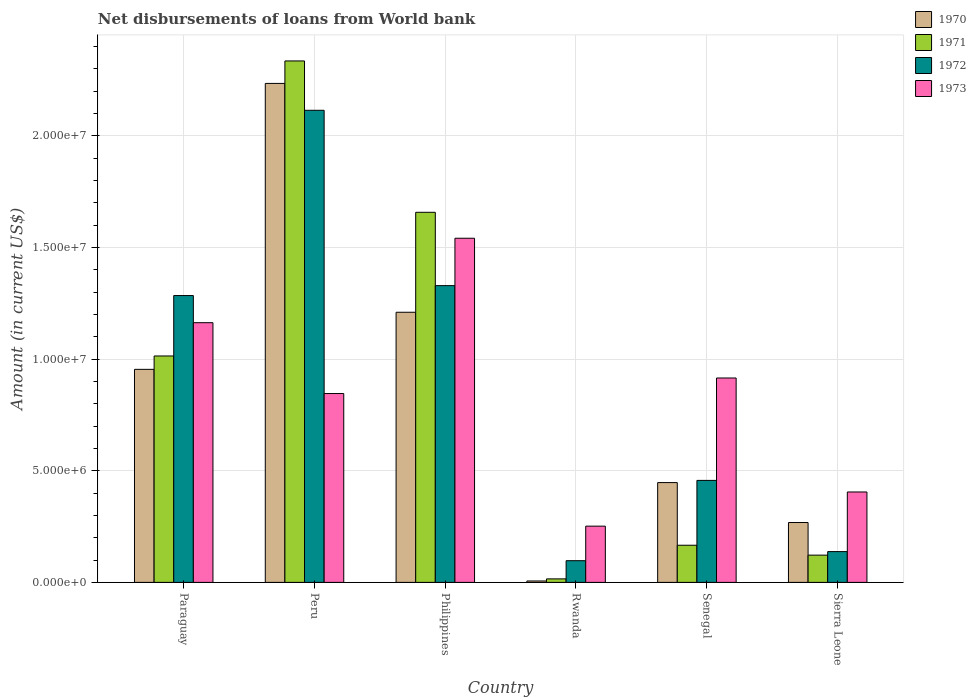How many different coloured bars are there?
Your answer should be compact. 4. How many bars are there on the 2nd tick from the left?
Offer a terse response. 4. What is the label of the 6th group of bars from the left?
Your answer should be very brief. Sierra Leone. In how many cases, is the number of bars for a given country not equal to the number of legend labels?
Ensure brevity in your answer.  0. What is the amount of loan disbursed from World Bank in 1970 in Rwanda?
Make the answer very short. 6.30e+04. Across all countries, what is the maximum amount of loan disbursed from World Bank in 1972?
Offer a terse response. 2.11e+07. Across all countries, what is the minimum amount of loan disbursed from World Bank in 1971?
Your answer should be very brief. 1.57e+05. In which country was the amount of loan disbursed from World Bank in 1973 minimum?
Keep it short and to the point. Rwanda. What is the total amount of loan disbursed from World Bank in 1970 in the graph?
Offer a very short reply. 5.12e+07. What is the difference between the amount of loan disbursed from World Bank in 1971 in Philippines and that in Senegal?
Your answer should be compact. 1.49e+07. What is the difference between the amount of loan disbursed from World Bank in 1971 in Paraguay and the amount of loan disbursed from World Bank in 1970 in Senegal?
Offer a terse response. 5.67e+06. What is the average amount of loan disbursed from World Bank in 1971 per country?
Make the answer very short. 8.85e+06. What is the difference between the amount of loan disbursed from World Bank of/in 1973 and amount of loan disbursed from World Bank of/in 1970 in Senegal?
Give a very brief answer. 4.68e+06. In how many countries, is the amount of loan disbursed from World Bank in 1971 greater than 23000000 US$?
Your answer should be compact. 1. What is the ratio of the amount of loan disbursed from World Bank in 1972 in Philippines to that in Senegal?
Your answer should be compact. 2.91. Is the amount of loan disbursed from World Bank in 1971 in Peru less than that in Sierra Leone?
Provide a short and direct response. No. What is the difference between the highest and the second highest amount of loan disbursed from World Bank in 1970?
Give a very brief answer. 1.02e+07. What is the difference between the highest and the lowest amount of loan disbursed from World Bank in 1970?
Provide a succinct answer. 2.23e+07. Is it the case that in every country, the sum of the amount of loan disbursed from World Bank in 1973 and amount of loan disbursed from World Bank in 1972 is greater than the sum of amount of loan disbursed from World Bank in 1971 and amount of loan disbursed from World Bank in 1970?
Make the answer very short. No. What does the 1st bar from the left in Sierra Leone represents?
Offer a terse response. 1970. How many bars are there?
Give a very brief answer. 24. How many countries are there in the graph?
Your answer should be compact. 6. What is the difference between two consecutive major ticks on the Y-axis?
Your response must be concise. 5.00e+06. Does the graph contain grids?
Your response must be concise. Yes. Where does the legend appear in the graph?
Provide a succinct answer. Top right. How many legend labels are there?
Provide a short and direct response. 4. How are the legend labels stacked?
Your answer should be compact. Vertical. What is the title of the graph?
Provide a succinct answer. Net disbursements of loans from World bank. What is the label or title of the X-axis?
Provide a succinct answer. Country. What is the Amount (in current US$) in 1970 in Paraguay?
Offer a terse response. 9.54e+06. What is the Amount (in current US$) in 1971 in Paraguay?
Make the answer very short. 1.01e+07. What is the Amount (in current US$) in 1972 in Paraguay?
Your answer should be compact. 1.28e+07. What is the Amount (in current US$) of 1973 in Paraguay?
Provide a short and direct response. 1.16e+07. What is the Amount (in current US$) of 1970 in Peru?
Ensure brevity in your answer.  2.23e+07. What is the Amount (in current US$) in 1971 in Peru?
Make the answer very short. 2.33e+07. What is the Amount (in current US$) of 1972 in Peru?
Keep it short and to the point. 2.11e+07. What is the Amount (in current US$) in 1973 in Peru?
Give a very brief answer. 8.46e+06. What is the Amount (in current US$) of 1970 in Philippines?
Offer a terse response. 1.21e+07. What is the Amount (in current US$) of 1971 in Philippines?
Provide a short and direct response. 1.66e+07. What is the Amount (in current US$) in 1972 in Philippines?
Offer a terse response. 1.33e+07. What is the Amount (in current US$) of 1973 in Philippines?
Provide a succinct answer. 1.54e+07. What is the Amount (in current US$) in 1970 in Rwanda?
Offer a terse response. 6.30e+04. What is the Amount (in current US$) of 1971 in Rwanda?
Ensure brevity in your answer.  1.57e+05. What is the Amount (in current US$) of 1972 in Rwanda?
Your answer should be very brief. 9.71e+05. What is the Amount (in current US$) of 1973 in Rwanda?
Your response must be concise. 2.52e+06. What is the Amount (in current US$) in 1970 in Senegal?
Your answer should be very brief. 4.47e+06. What is the Amount (in current US$) of 1971 in Senegal?
Make the answer very short. 1.66e+06. What is the Amount (in current US$) in 1972 in Senegal?
Your response must be concise. 4.57e+06. What is the Amount (in current US$) of 1973 in Senegal?
Make the answer very short. 9.15e+06. What is the Amount (in current US$) of 1970 in Sierra Leone?
Your answer should be very brief. 2.68e+06. What is the Amount (in current US$) in 1971 in Sierra Leone?
Provide a succinct answer. 1.22e+06. What is the Amount (in current US$) of 1972 in Sierra Leone?
Offer a very short reply. 1.38e+06. What is the Amount (in current US$) of 1973 in Sierra Leone?
Make the answer very short. 4.05e+06. Across all countries, what is the maximum Amount (in current US$) of 1970?
Give a very brief answer. 2.23e+07. Across all countries, what is the maximum Amount (in current US$) in 1971?
Your response must be concise. 2.33e+07. Across all countries, what is the maximum Amount (in current US$) in 1972?
Provide a succinct answer. 2.11e+07. Across all countries, what is the maximum Amount (in current US$) of 1973?
Offer a terse response. 1.54e+07. Across all countries, what is the minimum Amount (in current US$) in 1970?
Keep it short and to the point. 6.30e+04. Across all countries, what is the minimum Amount (in current US$) in 1971?
Give a very brief answer. 1.57e+05. Across all countries, what is the minimum Amount (in current US$) in 1972?
Keep it short and to the point. 9.71e+05. Across all countries, what is the minimum Amount (in current US$) of 1973?
Provide a short and direct response. 2.52e+06. What is the total Amount (in current US$) in 1970 in the graph?
Your answer should be compact. 5.12e+07. What is the total Amount (in current US$) of 1971 in the graph?
Make the answer very short. 5.31e+07. What is the total Amount (in current US$) of 1972 in the graph?
Your answer should be compact. 5.42e+07. What is the total Amount (in current US$) in 1973 in the graph?
Ensure brevity in your answer.  5.12e+07. What is the difference between the Amount (in current US$) in 1970 in Paraguay and that in Peru?
Offer a terse response. -1.28e+07. What is the difference between the Amount (in current US$) in 1971 in Paraguay and that in Peru?
Offer a very short reply. -1.32e+07. What is the difference between the Amount (in current US$) of 1972 in Paraguay and that in Peru?
Make the answer very short. -8.30e+06. What is the difference between the Amount (in current US$) in 1973 in Paraguay and that in Peru?
Your answer should be very brief. 3.17e+06. What is the difference between the Amount (in current US$) of 1970 in Paraguay and that in Philippines?
Provide a short and direct response. -2.56e+06. What is the difference between the Amount (in current US$) of 1971 in Paraguay and that in Philippines?
Your response must be concise. -6.43e+06. What is the difference between the Amount (in current US$) in 1972 in Paraguay and that in Philippines?
Your response must be concise. -4.44e+05. What is the difference between the Amount (in current US$) in 1973 in Paraguay and that in Philippines?
Make the answer very short. -3.78e+06. What is the difference between the Amount (in current US$) of 1970 in Paraguay and that in Rwanda?
Your answer should be compact. 9.48e+06. What is the difference between the Amount (in current US$) of 1971 in Paraguay and that in Rwanda?
Give a very brief answer. 9.98e+06. What is the difference between the Amount (in current US$) in 1972 in Paraguay and that in Rwanda?
Make the answer very short. 1.19e+07. What is the difference between the Amount (in current US$) of 1973 in Paraguay and that in Rwanda?
Your response must be concise. 9.11e+06. What is the difference between the Amount (in current US$) of 1970 in Paraguay and that in Senegal?
Your response must be concise. 5.07e+06. What is the difference between the Amount (in current US$) of 1971 in Paraguay and that in Senegal?
Keep it short and to the point. 8.47e+06. What is the difference between the Amount (in current US$) of 1972 in Paraguay and that in Senegal?
Offer a very short reply. 8.28e+06. What is the difference between the Amount (in current US$) of 1973 in Paraguay and that in Senegal?
Provide a succinct answer. 2.48e+06. What is the difference between the Amount (in current US$) of 1970 in Paraguay and that in Sierra Leone?
Your response must be concise. 6.86e+06. What is the difference between the Amount (in current US$) of 1971 in Paraguay and that in Sierra Leone?
Your answer should be compact. 8.92e+06. What is the difference between the Amount (in current US$) of 1972 in Paraguay and that in Sierra Leone?
Your answer should be very brief. 1.15e+07. What is the difference between the Amount (in current US$) in 1973 in Paraguay and that in Sierra Leone?
Ensure brevity in your answer.  7.58e+06. What is the difference between the Amount (in current US$) in 1970 in Peru and that in Philippines?
Keep it short and to the point. 1.02e+07. What is the difference between the Amount (in current US$) in 1971 in Peru and that in Philippines?
Your answer should be very brief. 6.78e+06. What is the difference between the Amount (in current US$) of 1972 in Peru and that in Philippines?
Offer a very short reply. 7.85e+06. What is the difference between the Amount (in current US$) of 1973 in Peru and that in Philippines?
Your answer should be compact. -6.95e+06. What is the difference between the Amount (in current US$) of 1970 in Peru and that in Rwanda?
Offer a very short reply. 2.23e+07. What is the difference between the Amount (in current US$) in 1971 in Peru and that in Rwanda?
Give a very brief answer. 2.32e+07. What is the difference between the Amount (in current US$) of 1972 in Peru and that in Rwanda?
Provide a succinct answer. 2.02e+07. What is the difference between the Amount (in current US$) of 1973 in Peru and that in Rwanda?
Make the answer very short. 5.94e+06. What is the difference between the Amount (in current US$) of 1970 in Peru and that in Senegal?
Provide a short and direct response. 1.79e+07. What is the difference between the Amount (in current US$) of 1971 in Peru and that in Senegal?
Offer a very short reply. 2.17e+07. What is the difference between the Amount (in current US$) of 1972 in Peru and that in Senegal?
Provide a succinct answer. 1.66e+07. What is the difference between the Amount (in current US$) in 1973 in Peru and that in Senegal?
Your response must be concise. -6.96e+05. What is the difference between the Amount (in current US$) in 1970 in Peru and that in Sierra Leone?
Ensure brevity in your answer.  1.97e+07. What is the difference between the Amount (in current US$) in 1971 in Peru and that in Sierra Leone?
Give a very brief answer. 2.21e+07. What is the difference between the Amount (in current US$) in 1972 in Peru and that in Sierra Leone?
Give a very brief answer. 1.98e+07. What is the difference between the Amount (in current US$) in 1973 in Peru and that in Sierra Leone?
Provide a short and direct response. 4.41e+06. What is the difference between the Amount (in current US$) in 1970 in Philippines and that in Rwanda?
Keep it short and to the point. 1.20e+07. What is the difference between the Amount (in current US$) in 1971 in Philippines and that in Rwanda?
Provide a short and direct response. 1.64e+07. What is the difference between the Amount (in current US$) of 1972 in Philippines and that in Rwanda?
Give a very brief answer. 1.23e+07. What is the difference between the Amount (in current US$) in 1973 in Philippines and that in Rwanda?
Provide a succinct answer. 1.29e+07. What is the difference between the Amount (in current US$) in 1970 in Philippines and that in Senegal?
Give a very brief answer. 7.63e+06. What is the difference between the Amount (in current US$) in 1971 in Philippines and that in Senegal?
Your answer should be very brief. 1.49e+07. What is the difference between the Amount (in current US$) of 1972 in Philippines and that in Senegal?
Keep it short and to the point. 8.72e+06. What is the difference between the Amount (in current US$) of 1973 in Philippines and that in Senegal?
Offer a terse response. 6.26e+06. What is the difference between the Amount (in current US$) in 1970 in Philippines and that in Sierra Leone?
Provide a short and direct response. 9.41e+06. What is the difference between the Amount (in current US$) in 1971 in Philippines and that in Sierra Leone?
Provide a short and direct response. 1.53e+07. What is the difference between the Amount (in current US$) in 1972 in Philippines and that in Sierra Leone?
Give a very brief answer. 1.19e+07. What is the difference between the Amount (in current US$) of 1973 in Philippines and that in Sierra Leone?
Offer a terse response. 1.14e+07. What is the difference between the Amount (in current US$) in 1970 in Rwanda and that in Senegal?
Your response must be concise. -4.40e+06. What is the difference between the Amount (in current US$) of 1971 in Rwanda and that in Senegal?
Keep it short and to the point. -1.51e+06. What is the difference between the Amount (in current US$) of 1972 in Rwanda and that in Senegal?
Offer a terse response. -3.60e+06. What is the difference between the Amount (in current US$) in 1973 in Rwanda and that in Senegal?
Offer a very short reply. -6.63e+06. What is the difference between the Amount (in current US$) in 1970 in Rwanda and that in Sierra Leone?
Keep it short and to the point. -2.62e+06. What is the difference between the Amount (in current US$) in 1971 in Rwanda and that in Sierra Leone?
Make the answer very short. -1.06e+06. What is the difference between the Amount (in current US$) in 1972 in Rwanda and that in Sierra Leone?
Your answer should be very brief. -4.07e+05. What is the difference between the Amount (in current US$) in 1973 in Rwanda and that in Sierra Leone?
Your answer should be compact. -1.53e+06. What is the difference between the Amount (in current US$) in 1970 in Senegal and that in Sierra Leone?
Ensure brevity in your answer.  1.79e+06. What is the difference between the Amount (in current US$) of 1971 in Senegal and that in Sierra Leone?
Your response must be concise. 4.43e+05. What is the difference between the Amount (in current US$) in 1972 in Senegal and that in Sierra Leone?
Your response must be concise. 3.19e+06. What is the difference between the Amount (in current US$) of 1973 in Senegal and that in Sierra Leone?
Provide a short and direct response. 5.10e+06. What is the difference between the Amount (in current US$) of 1970 in Paraguay and the Amount (in current US$) of 1971 in Peru?
Keep it short and to the point. -1.38e+07. What is the difference between the Amount (in current US$) of 1970 in Paraguay and the Amount (in current US$) of 1972 in Peru?
Your response must be concise. -1.16e+07. What is the difference between the Amount (in current US$) of 1970 in Paraguay and the Amount (in current US$) of 1973 in Peru?
Offer a terse response. 1.08e+06. What is the difference between the Amount (in current US$) of 1971 in Paraguay and the Amount (in current US$) of 1972 in Peru?
Your response must be concise. -1.10e+07. What is the difference between the Amount (in current US$) in 1971 in Paraguay and the Amount (in current US$) in 1973 in Peru?
Provide a succinct answer. 1.68e+06. What is the difference between the Amount (in current US$) of 1972 in Paraguay and the Amount (in current US$) of 1973 in Peru?
Make the answer very short. 4.39e+06. What is the difference between the Amount (in current US$) in 1970 in Paraguay and the Amount (in current US$) in 1971 in Philippines?
Your answer should be compact. -7.03e+06. What is the difference between the Amount (in current US$) of 1970 in Paraguay and the Amount (in current US$) of 1972 in Philippines?
Provide a succinct answer. -3.75e+06. What is the difference between the Amount (in current US$) of 1970 in Paraguay and the Amount (in current US$) of 1973 in Philippines?
Give a very brief answer. -5.87e+06. What is the difference between the Amount (in current US$) of 1971 in Paraguay and the Amount (in current US$) of 1972 in Philippines?
Your answer should be compact. -3.15e+06. What is the difference between the Amount (in current US$) in 1971 in Paraguay and the Amount (in current US$) in 1973 in Philippines?
Give a very brief answer. -5.27e+06. What is the difference between the Amount (in current US$) of 1972 in Paraguay and the Amount (in current US$) of 1973 in Philippines?
Ensure brevity in your answer.  -2.57e+06. What is the difference between the Amount (in current US$) of 1970 in Paraguay and the Amount (in current US$) of 1971 in Rwanda?
Keep it short and to the point. 9.38e+06. What is the difference between the Amount (in current US$) in 1970 in Paraguay and the Amount (in current US$) in 1972 in Rwanda?
Provide a short and direct response. 8.57e+06. What is the difference between the Amount (in current US$) in 1970 in Paraguay and the Amount (in current US$) in 1973 in Rwanda?
Your answer should be very brief. 7.02e+06. What is the difference between the Amount (in current US$) of 1971 in Paraguay and the Amount (in current US$) of 1972 in Rwanda?
Provide a succinct answer. 9.17e+06. What is the difference between the Amount (in current US$) of 1971 in Paraguay and the Amount (in current US$) of 1973 in Rwanda?
Your answer should be compact. 7.62e+06. What is the difference between the Amount (in current US$) of 1972 in Paraguay and the Amount (in current US$) of 1973 in Rwanda?
Your response must be concise. 1.03e+07. What is the difference between the Amount (in current US$) in 1970 in Paraguay and the Amount (in current US$) in 1971 in Senegal?
Provide a short and direct response. 7.88e+06. What is the difference between the Amount (in current US$) in 1970 in Paraguay and the Amount (in current US$) in 1972 in Senegal?
Ensure brevity in your answer.  4.97e+06. What is the difference between the Amount (in current US$) in 1970 in Paraguay and the Amount (in current US$) in 1973 in Senegal?
Offer a very short reply. 3.87e+05. What is the difference between the Amount (in current US$) in 1971 in Paraguay and the Amount (in current US$) in 1972 in Senegal?
Give a very brief answer. 5.57e+06. What is the difference between the Amount (in current US$) of 1971 in Paraguay and the Amount (in current US$) of 1973 in Senegal?
Your response must be concise. 9.86e+05. What is the difference between the Amount (in current US$) in 1972 in Paraguay and the Amount (in current US$) in 1973 in Senegal?
Keep it short and to the point. 3.69e+06. What is the difference between the Amount (in current US$) of 1970 in Paraguay and the Amount (in current US$) of 1971 in Sierra Leone?
Ensure brevity in your answer.  8.32e+06. What is the difference between the Amount (in current US$) in 1970 in Paraguay and the Amount (in current US$) in 1972 in Sierra Leone?
Keep it short and to the point. 8.16e+06. What is the difference between the Amount (in current US$) of 1970 in Paraguay and the Amount (in current US$) of 1973 in Sierra Leone?
Keep it short and to the point. 5.49e+06. What is the difference between the Amount (in current US$) in 1971 in Paraguay and the Amount (in current US$) in 1972 in Sierra Leone?
Make the answer very short. 8.76e+06. What is the difference between the Amount (in current US$) of 1971 in Paraguay and the Amount (in current US$) of 1973 in Sierra Leone?
Keep it short and to the point. 6.09e+06. What is the difference between the Amount (in current US$) of 1972 in Paraguay and the Amount (in current US$) of 1973 in Sierra Leone?
Provide a short and direct response. 8.79e+06. What is the difference between the Amount (in current US$) of 1970 in Peru and the Amount (in current US$) of 1971 in Philippines?
Your answer should be very brief. 5.77e+06. What is the difference between the Amount (in current US$) in 1970 in Peru and the Amount (in current US$) in 1972 in Philippines?
Make the answer very short. 9.05e+06. What is the difference between the Amount (in current US$) in 1970 in Peru and the Amount (in current US$) in 1973 in Philippines?
Offer a very short reply. 6.93e+06. What is the difference between the Amount (in current US$) in 1971 in Peru and the Amount (in current US$) in 1972 in Philippines?
Your answer should be very brief. 1.01e+07. What is the difference between the Amount (in current US$) in 1971 in Peru and the Amount (in current US$) in 1973 in Philippines?
Your answer should be compact. 7.94e+06. What is the difference between the Amount (in current US$) of 1972 in Peru and the Amount (in current US$) of 1973 in Philippines?
Give a very brief answer. 5.73e+06. What is the difference between the Amount (in current US$) of 1970 in Peru and the Amount (in current US$) of 1971 in Rwanda?
Make the answer very short. 2.22e+07. What is the difference between the Amount (in current US$) in 1970 in Peru and the Amount (in current US$) in 1972 in Rwanda?
Your response must be concise. 2.14e+07. What is the difference between the Amount (in current US$) in 1970 in Peru and the Amount (in current US$) in 1973 in Rwanda?
Give a very brief answer. 1.98e+07. What is the difference between the Amount (in current US$) in 1971 in Peru and the Amount (in current US$) in 1972 in Rwanda?
Offer a terse response. 2.24e+07. What is the difference between the Amount (in current US$) in 1971 in Peru and the Amount (in current US$) in 1973 in Rwanda?
Offer a terse response. 2.08e+07. What is the difference between the Amount (in current US$) in 1972 in Peru and the Amount (in current US$) in 1973 in Rwanda?
Your answer should be compact. 1.86e+07. What is the difference between the Amount (in current US$) in 1970 in Peru and the Amount (in current US$) in 1971 in Senegal?
Your answer should be compact. 2.07e+07. What is the difference between the Amount (in current US$) in 1970 in Peru and the Amount (in current US$) in 1972 in Senegal?
Ensure brevity in your answer.  1.78e+07. What is the difference between the Amount (in current US$) of 1970 in Peru and the Amount (in current US$) of 1973 in Senegal?
Give a very brief answer. 1.32e+07. What is the difference between the Amount (in current US$) of 1971 in Peru and the Amount (in current US$) of 1972 in Senegal?
Make the answer very short. 1.88e+07. What is the difference between the Amount (in current US$) of 1971 in Peru and the Amount (in current US$) of 1973 in Senegal?
Offer a very short reply. 1.42e+07. What is the difference between the Amount (in current US$) of 1972 in Peru and the Amount (in current US$) of 1973 in Senegal?
Your response must be concise. 1.20e+07. What is the difference between the Amount (in current US$) of 1970 in Peru and the Amount (in current US$) of 1971 in Sierra Leone?
Offer a terse response. 2.11e+07. What is the difference between the Amount (in current US$) in 1970 in Peru and the Amount (in current US$) in 1972 in Sierra Leone?
Provide a short and direct response. 2.10e+07. What is the difference between the Amount (in current US$) in 1970 in Peru and the Amount (in current US$) in 1973 in Sierra Leone?
Give a very brief answer. 1.83e+07. What is the difference between the Amount (in current US$) in 1971 in Peru and the Amount (in current US$) in 1972 in Sierra Leone?
Your answer should be very brief. 2.20e+07. What is the difference between the Amount (in current US$) in 1971 in Peru and the Amount (in current US$) in 1973 in Sierra Leone?
Keep it short and to the point. 1.93e+07. What is the difference between the Amount (in current US$) of 1972 in Peru and the Amount (in current US$) of 1973 in Sierra Leone?
Offer a very short reply. 1.71e+07. What is the difference between the Amount (in current US$) in 1970 in Philippines and the Amount (in current US$) in 1971 in Rwanda?
Keep it short and to the point. 1.19e+07. What is the difference between the Amount (in current US$) of 1970 in Philippines and the Amount (in current US$) of 1972 in Rwanda?
Give a very brief answer. 1.11e+07. What is the difference between the Amount (in current US$) in 1970 in Philippines and the Amount (in current US$) in 1973 in Rwanda?
Provide a short and direct response. 9.58e+06. What is the difference between the Amount (in current US$) of 1971 in Philippines and the Amount (in current US$) of 1972 in Rwanda?
Provide a short and direct response. 1.56e+07. What is the difference between the Amount (in current US$) of 1971 in Philippines and the Amount (in current US$) of 1973 in Rwanda?
Provide a succinct answer. 1.41e+07. What is the difference between the Amount (in current US$) in 1972 in Philippines and the Amount (in current US$) in 1973 in Rwanda?
Offer a terse response. 1.08e+07. What is the difference between the Amount (in current US$) in 1970 in Philippines and the Amount (in current US$) in 1971 in Senegal?
Your response must be concise. 1.04e+07. What is the difference between the Amount (in current US$) of 1970 in Philippines and the Amount (in current US$) of 1972 in Senegal?
Provide a short and direct response. 7.53e+06. What is the difference between the Amount (in current US$) in 1970 in Philippines and the Amount (in current US$) in 1973 in Senegal?
Give a very brief answer. 2.94e+06. What is the difference between the Amount (in current US$) of 1971 in Philippines and the Amount (in current US$) of 1972 in Senegal?
Give a very brief answer. 1.20e+07. What is the difference between the Amount (in current US$) in 1971 in Philippines and the Amount (in current US$) in 1973 in Senegal?
Make the answer very short. 7.42e+06. What is the difference between the Amount (in current US$) in 1972 in Philippines and the Amount (in current US$) in 1973 in Senegal?
Your answer should be compact. 4.14e+06. What is the difference between the Amount (in current US$) in 1970 in Philippines and the Amount (in current US$) in 1971 in Sierra Leone?
Provide a short and direct response. 1.09e+07. What is the difference between the Amount (in current US$) in 1970 in Philippines and the Amount (in current US$) in 1972 in Sierra Leone?
Offer a very short reply. 1.07e+07. What is the difference between the Amount (in current US$) in 1970 in Philippines and the Amount (in current US$) in 1973 in Sierra Leone?
Provide a succinct answer. 8.05e+06. What is the difference between the Amount (in current US$) of 1971 in Philippines and the Amount (in current US$) of 1972 in Sierra Leone?
Offer a very short reply. 1.52e+07. What is the difference between the Amount (in current US$) of 1971 in Philippines and the Amount (in current US$) of 1973 in Sierra Leone?
Your response must be concise. 1.25e+07. What is the difference between the Amount (in current US$) of 1972 in Philippines and the Amount (in current US$) of 1973 in Sierra Leone?
Ensure brevity in your answer.  9.24e+06. What is the difference between the Amount (in current US$) in 1970 in Rwanda and the Amount (in current US$) in 1971 in Senegal?
Your answer should be compact. -1.60e+06. What is the difference between the Amount (in current US$) in 1970 in Rwanda and the Amount (in current US$) in 1972 in Senegal?
Keep it short and to the point. -4.50e+06. What is the difference between the Amount (in current US$) in 1970 in Rwanda and the Amount (in current US$) in 1973 in Senegal?
Your answer should be very brief. -9.09e+06. What is the difference between the Amount (in current US$) in 1971 in Rwanda and the Amount (in current US$) in 1972 in Senegal?
Give a very brief answer. -4.41e+06. What is the difference between the Amount (in current US$) of 1971 in Rwanda and the Amount (in current US$) of 1973 in Senegal?
Give a very brief answer. -8.99e+06. What is the difference between the Amount (in current US$) in 1972 in Rwanda and the Amount (in current US$) in 1973 in Senegal?
Make the answer very short. -8.18e+06. What is the difference between the Amount (in current US$) in 1970 in Rwanda and the Amount (in current US$) in 1971 in Sierra Leone?
Offer a terse response. -1.16e+06. What is the difference between the Amount (in current US$) of 1970 in Rwanda and the Amount (in current US$) of 1972 in Sierra Leone?
Offer a very short reply. -1.32e+06. What is the difference between the Amount (in current US$) in 1970 in Rwanda and the Amount (in current US$) in 1973 in Sierra Leone?
Your response must be concise. -3.98e+06. What is the difference between the Amount (in current US$) in 1971 in Rwanda and the Amount (in current US$) in 1972 in Sierra Leone?
Provide a short and direct response. -1.22e+06. What is the difference between the Amount (in current US$) of 1971 in Rwanda and the Amount (in current US$) of 1973 in Sierra Leone?
Offer a very short reply. -3.89e+06. What is the difference between the Amount (in current US$) in 1972 in Rwanda and the Amount (in current US$) in 1973 in Sierra Leone?
Offer a very short reply. -3.08e+06. What is the difference between the Amount (in current US$) of 1970 in Senegal and the Amount (in current US$) of 1971 in Sierra Leone?
Your response must be concise. 3.25e+06. What is the difference between the Amount (in current US$) in 1970 in Senegal and the Amount (in current US$) in 1972 in Sierra Leone?
Give a very brief answer. 3.09e+06. What is the difference between the Amount (in current US$) of 1971 in Senegal and the Amount (in current US$) of 1972 in Sierra Leone?
Offer a terse response. 2.85e+05. What is the difference between the Amount (in current US$) in 1971 in Senegal and the Amount (in current US$) in 1973 in Sierra Leone?
Provide a short and direct response. -2.38e+06. What is the difference between the Amount (in current US$) in 1972 in Senegal and the Amount (in current US$) in 1973 in Sierra Leone?
Keep it short and to the point. 5.18e+05. What is the average Amount (in current US$) in 1970 per country?
Your answer should be very brief. 8.53e+06. What is the average Amount (in current US$) in 1971 per country?
Keep it short and to the point. 8.85e+06. What is the average Amount (in current US$) in 1972 per country?
Keep it short and to the point. 9.03e+06. What is the average Amount (in current US$) of 1973 per country?
Your answer should be compact. 8.53e+06. What is the difference between the Amount (in current US$) in 1970 and Amount (in current US$) in 1971 in Paraguay?
Provide a short and direct response. -5.99e+05. What is the difference between the Amount (in current US$) of 1970 and Amount (in current US$) of 1972 in Paraguay?
Offer a very short reply. -3.30e+06. What is the difference between the Amount (in current US$) in 1970 and Amount (in current US$) in 1973 in Paraguay?
Your answer should be very brief. -2.09e+06. What is the difference between the Amount (in current US$) in 1971 and Amount (in current US$) in 1972 in Paraguay?
Offer a very short reply. -2.70e+06. What is the difference between the Amount (in current US$) of 1971 and Amount (in current US$) of 1973 in Paraguay?
Give a very brief answer. -1.49e+06. What is the difference between the Amount (in current US$) in 1972 and Amount (in current US$) in 1973 in Paraguay?
Provide a short and direct response. 1.22e+06. What is the difference between the Amount (in current US$) of 1970 and Amount (in current US$) of 1971 in Peru?
Give a very brief answer. -1.01e+06. What is the difference between the Amount (in current US$) of 1970 and Amount (in current US$) of 1972 in Peru?
Ensure brevity in your answer.  1.20e+06. What is the difference between the Amount (in current US$) in 1970 and Amount (in current US$) in 1973 in Peru?
Your answer should be compact. 1.39e+07. What is the difference between the Amount (in current US$) of 1971 and Amount (in current US$) of 1972 in Peru?
Ensure brevity in your answer.  2.21e+06. What is the difference between the Amount (in current US$) of 1971 and Amount (in current US$) of 1973 in Peru?
Your response must be concise. 1.49e+07. What is the difference between the Amount (in current US$) of 1972 and Amount (in current US$) of 1973 in Peru?
Offer a terse response. 1.27e+07. What is the difference between the Amount (in current US$) of 1970 and Amount (in current US$) of 1971 in Philippines?
Keep it short and to the point. -4.48e+06. What is the difference between the Amount (in current US$) of 1970 and Amount (in current US$) of 1972 in Philippines?
Ensure brevity in your answer.  -1.19e+06. What is the difference between the Amount (in current US$) in 1970 and Amount (in current US$) in 1973 in Philippines?
Offer a terse response. -3.31e+06. What is the difference between the Amount (in current US$) of 1971 and Amount (in current US$) of 1972 in Philippines?
Your response must be concise. 3.28e+06. What is the difference between the Amount (in current US$) of 1971 and Amount (in current US$) of 1973 in Philippines?
Give a very brief answer. 1.16e+06. What is the difference between the Amount (in current US$) in 1972 and Amount (in current US$) in 1973 in Philippines?
Your response must be concise. -2.12e+06. What is the difference between the Amount (in current US$) in 1970 and Amount (in current US$) in 1971 in Rwanda?
Provide a short and direct response. -9.40e+04. What is the difference between the Amount (in current US$) in 1970 and Amount (in current US$) in 1972 in Rwanda?
Your answer should be compact. -9.08e+05. What is the difference between the Amount (in current US$) in 1970 and Amount (in current US$) in 1973 in Rwanda?
Offer a terse response. -2.46e+06. What is the difference between the Amount (in current US$) in 1971 and Amount (in current US$) in 1972 in Rwanda?
Provide a short and direct response. -8.14e+05. What is the difference between the Amount (in current US$) of 1971 and Amount (in current US$) of 1973 in Rwanda?
Provide a short and direct response. -2.36e+06. What is the difference between the Amount (in current US$) of 1972 and Amount (in current US$) of 1973 in Rwanda?
Make the answer very short. -1.55e+06. What is the difference between the Amount (in current US$) of 1970 and Amount (in current US$) of 1971 in Senegal?
Give a very brief answer. 2.80e+06. What is the difference between the Amount (in current US$) of 1970 and Amount (in current US$) of 1972 in Senegal?
Give a very brief answer. -9.80e+04. What is the difference between the Amount (in current US$) in 1970 and Amount (in current US$) in 1973 in Senegal?
Offer a very short reply. -4.68e+06. What is the difference between the Amount (in current US$) of 1971 and Amount (in current US$) of 1972 in Senegal?
Your answer should be compact. -2.90e+06. What is the difference between the Amount (in current US$) in 1971 and Amount (in current US$) in 1973 in Senegal?
Make the answer very short. -7.49e+06. What is the difference between the Amount (in current US$) in 1972 and Amount (in current US$) in 1973 in Senegal?
Give a very brief answer. -4.58e+06. What is the difference between the Amount (in current US$) of 1970 and Amount (in current US$) of 1971 in Sierra Leone?
Ensure brevity in your answer.  1.46e+06. What is the difference between the Amount (in current US$) of 1970 and Amount (in current US$) of 1972 in Sierra Leone?
Offer a terse response. 1.30e+06. What is the difference between the Amount (in current US$) of 1970 and Amount (in current US$) of 1973 in Sierra Leone?
Provide a short and direct response. -1.37e+06. What is the difference between the Amount (in current US$) in 1971 and Amount (in current US$) in 1972 in Sierra Leone?
Offer a terse response. -1.58e+05. What is the difference between the Amount (in current US$) in 1971 and Amount (in current US$) in 1973 in Sierra Leone?
Provide a succinct answer. -2.83e+06. What is the difference between the Amount (in current US$) in 1972 and Amount (in current US$) in 1973 in Sierra Leone?
Provide a succinct answer. -2.67e+06. What is the ratio of the Amount (in current US$) in 1970 in Paraguay to that in Peru?
Make the answer very short. 0.43. What is the ratio of the Amount (in current US$) of 1971 in Paraguay to that in Peru?
Your response must be concise. 0.43. What is the ratio of the Amount (in current US$) of 1972 in Paraguay to that in Peru?
Provide a succinct answer. 0.61. What is the ratio of the Amount (in current US$) of 1973 in Paraguay to that in Peru?
Provide a short and direct response. 1.38. What is the ratio of the Amount (in current US$) of 1970 in Paraguay to that in Philippines?
Provide a short and direct response. 0.79. What is the ratio of the Amount (in current US$) in 1971 in Paraguay to that in Philippines?
Provide a short and direct response. 0.61. What is the ratio of the Amount (in current US$) of 1972 in Paraguay to that in Philippines?
Offer a terse response. 0.97. What is the ratio of the Amount (in current US$) of 1973 in Paraguay to that in Philippines?
Your answer should be very brief. 0.75. What is the ratio of the Amount (in current US$) of 1970 in Paraguay to that in Rwanda?
Provide a short and direct response. 151.4. What is the ratio of the Amount (in current US$) in 1971 in Paraguay to that in Rwanda?
Give a very brief answer. 64.57. What is the ratio of the Amount (in current US$) of 1972 in Paraguay to that in Rwanda?
Make the answer very short. 13.23. What is the ratio of the Amount (in current US$) of 1973 in Paraguay to that in Rwanda?
Ensure brevity in your answer.  4.62. What is the ratio of the Amount (in current US$) in 1970 in Paraguay to that in Senegal?
Offer a very short reply. 2.13. What is the ratio of the Amount (in current US$) in 1971 in Paraguay to that in Senegal?
Offer a very short reply. 6.1. What is the ratio of the Amount (in current US$) in 1972 in Paraguay to that in Senegal?
Your response must be concise. 2.81. What is the ratio of the Amount (in current US$) of 1973 in Paraguay to that in Senegal?
Provide a succinct answer. 1.27. What is the ratio of the Amount (in current US$) of 1970 in Paraguay to that in Sierra Leone?
Offer a very short reply. 3.56. What is the ratio of the Amount (in current US$) of 1971 in Paraguay to that in Sierra Leone?
Your answer should be very brief. 8.31. What is the ratio of the Amount (in current US$) in 1972 in Paraguay to that in Sierra Leone?
Give a very brief answer. 9.32. What is the ratio of the Amount (in current US$) of 1973 in Paraguay to that in Sierra Leone?
Make the answer very short. 2.87. What is the ratio of the Amount (in current US$) of 1970 in Peru to that in Philippines?
Ensure brevity in your answer.  1.85. What is the ratio of the Amount (in current US$) in 1971 in Peru to that in Philippines?
Your answer should be very brief. 1.41. What is the ratio of the Amount (in current US$) in 1972 in Peru to that in Philippines?
Keep it short and to the point. 1.59. What is the ratio of the Amount (in current US$) of 1973 in Peru to that in Philippines?
Keep it short and to the point. 0.55. What is the ratio of the Amount (in current US$) in 1970 in Peru to that in Rwanda?
Ensure brevity in your answer.  354.6. What is the ratio of the Amount (in current US$) of 1971 in Peru to that in Rwanda?
Provide a short and direct response. 148.7. What is the ratio of the Amount (in current US$) of 1972 in Peru to that in Rwanda?
Provide a short and direct response. 21.77. What is the ratio of the Amount (in current US$) of 1973 in Peru to that in Rwanda?
Your response must be concise. 3.36. What is the ratio of the Amount (in current US$) in 1970 in Peru to that in Senegal?
Provide a short and direct response. 5. What is the ratio of the Amount (in current US$) of 1971 in Peru to that in Senegal?
Offer a terse response. 14.04. What is the ratio of the Amount (in current US$) in 1972 in Peru to that in Senegal?
Offer a very short reply. 4.63. What is the ratio of the Amount (in current US$) of 1973 in Peru to that in Senegal?
Give a very brief answer. 0.92. What is the ratio of the Amount (in current US$) in 1970 in Peru to that in Sierra Leone?
Offer a terse response. 8.34. What is the ratio of the Amount (in current US$) of 1971 in Peru to that in Sierra Leone?
Your answer should be very brief. 19.14. What is the ratio of the Amount (in current US$) in 1972 in Peru to that in Sierra Leone?
Offer a very short reply. 15.34. What is the ratio of the Amount (in current US$) in 1973 in Peru to that in Sierra Leone?
Make the answer very short. 2.09. What is the ratio of the Amount (in current US$) in 1970 in Philippines to that in Rwanda?
Your answer should be very brief. 191.97. What is the ratio of the Amount (in current US$) in 1971 in Philippines to that in Rwanda?
Your response must be concise. 105.53. What is the ratio of the Amount (in current US$) of 1972 in Philippines to that in Rwanda?
Ensure brevity in your answer.  13.68. What is the ratio of the Amount (in current US$) of 1973 in Philippines to that in Rwanda?
Your answer should be compact. 6.12. What is the ratio of the Amount (in current US$) of 1970 in Philippines to that in Senegal?
Your answer should be compact. 2.71. What is the ratio of the Amount (in current US$) in 1971 in Philippines to that in Senegal?
Your response must be concise. 9.96. What is the ratio of the Amount (in current US$) of 1972 in Philippines to that in Senegal?
Provide a succinct answer. 2.91. What is the ratio of the Amount (in current US$) of 1973 in Philippines to that in Senegal?
Make the answer very short. 1.68. What is the ratio of the Amount (in current US$) in 1970 in Philippines to that in Sierra Leone?
Ensure brevity in your answer.  4.51. What is the ratio of the Amount (in current US$) of 1971 in Philippines to that in Sierra Leone?
Your answer should be very brief. 13.58. What is the ratio of the Amount (in current US$) of 1972 in Philippines to that in Sierra Leone?
Keep it short and to the point. 9.64. What is the ratio of the Amount (in current US$) in 1973 in Philippines to that in Sierra Leone?
Ensure brevity in your answer.  3.81. What is the ratio of the Amount (in current US$) of 1970 in Rwanda to that in Senegal?
Ensure brevity in your answer.  0.01. What is the ratio of the Amount (in current US$) of 1971 in Rwanda to that in Senegal?
Provide a short and direct response. 0.09. What is the ratio of the Amount (in current US$) in 1972 in Rwanda to that in Senegal?
Your answer should be very brief. 0.21. What is the ratio of the Amount (in current US$) of 1973 in Rwanda to that in Senegal?
Keep it short and to the point. 0.28. What is the ratio of the Amount (in current US$) of 1970 in Rwanda to that in Sierra Leone?
Make the answer very short. 0.02. What is the ratio of the Amount (in current US$) in 1971 in Rwanda to that in Sierra Leone?
Give a very brief answer. 0.13. What is the ratio of the Amount (in current US$) of 1972 in Rwanda to that in Sierra Leone?
Your response must be concise. 0.7. What is the ratio of the Amount (in current US$) of 1973 in Rwanda to that in Sierra Leone?
Your response must be concise. 0.62. What is the ratio of the Amount (in current US$) in 1970 in Senegal to that in Sierra Leone?
Offer a terse response. 1.67. What is the ratio of the Amount (in current US$) of 1971 in Senegal to that in Sierra Leone?
Offer a very short reply. 1.36. What is the ratio of the Amount (in current US$) in 1972 in Senegal to that in Sierra Leone?
Give a very brief answer. 3.31. What is the ratio of the Amount (in current US$) in 1973 in Senegal to that in Sierra Leone?
Give a very brief answer. 2.26. What is the difference between the highest and the second highest Amount (in current US$) of 1970?
Provide a succinct answer. 1.02e+07. What is the difference between the highest and the second highest Amount (in current US$) of 1971?
Your answer should be compact. 6.78e+06. What is the difference between the highest and the second highest Amount (in current US$) in 1972?
Offer a terse response. 7.85e+06. What is the difference between the highest and the second highest Amount (in current US$) of 1973?
Keep it short and to the point. 3.78e+06. What is the difference between the highest and the lowest Amount (in current US$) of 1970?
Give a very brief answer. 2.23e+07. What is the difference between the highest and the lowest Amount (in current US$) in 1971?
Make the answer very short. 2.32e+07. What is the difference between the highest and the lowest Amount (in current US$) in 1972?
Your answer should be very brief. 2.02e+07. What is the difference between the highest and the lowest Amount (in current US$) of 1973?
Give a very brief answer. 1.29e+07. 